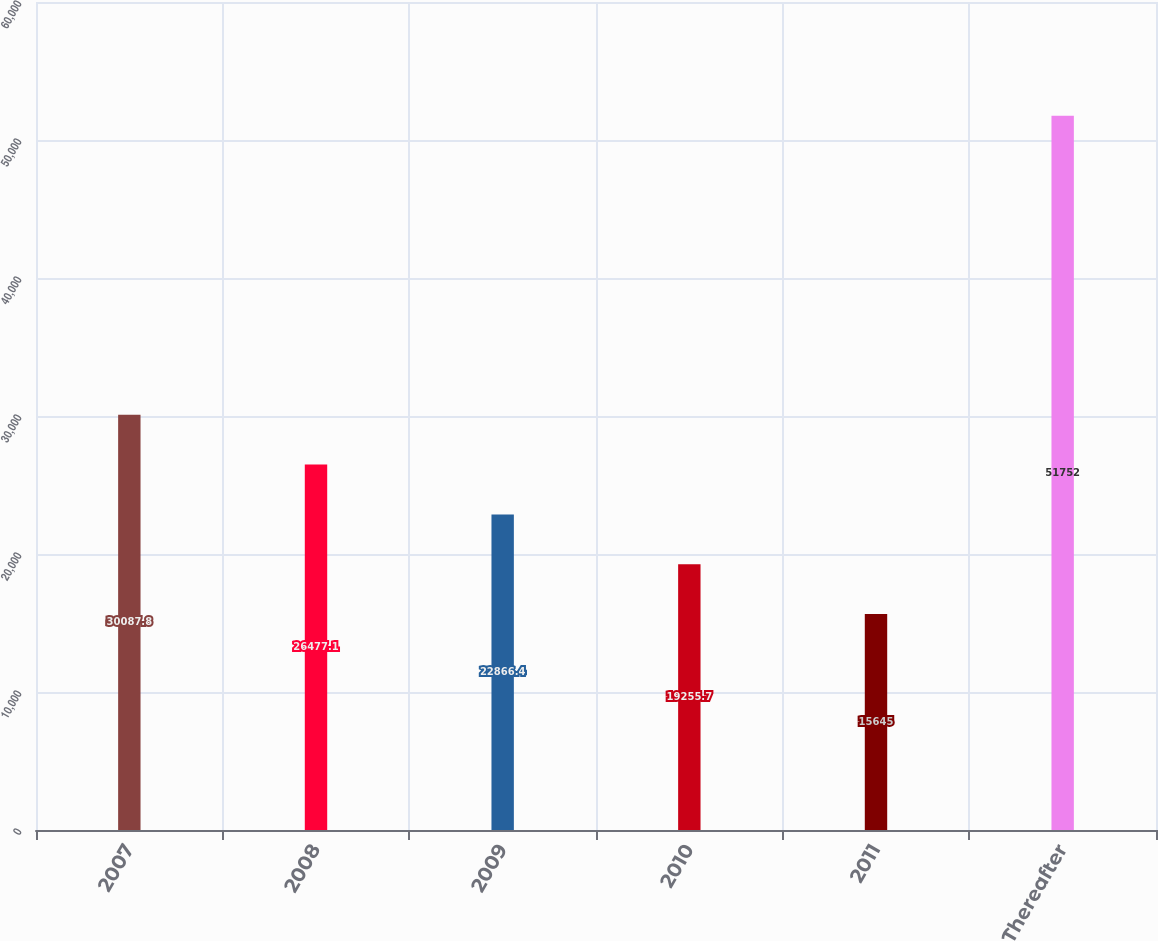Convert chart. <chart><loc_0><loc_0><loc_500><loc_500><bar_chart><fcel>2007<fcel>2008<fcel>2009<fcel>2010<fcel>2011<fcel>Thereafter<nl><fcel>30087.8<fcel>26477.1<fcel>22866.4<fcel>19255.7<fcel>15645<fcel>51752<nl></chart> 